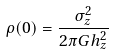<formula> <loc_0><loc_0><loc_500><loc_500>\rho ( 0 ) = \frac { \sigma _ { z } ^ { 2 } } { 2 \pi G h _ { z } ^ { 2 } }</formula> 